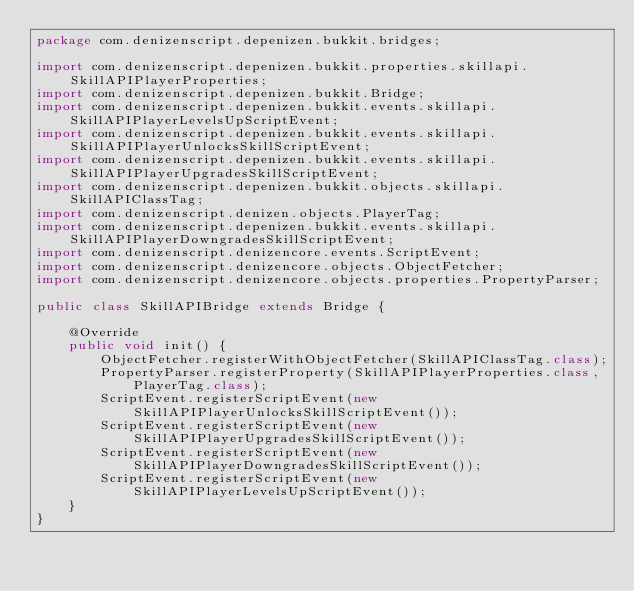<code> <loc_0><loc_0><loc_500><loc_500><_Java_>package com.denizenscript.depenizen.bukkit.bridges;

import com.denizenscript.depenizen.bukkit.properties.skillapi.SkillAPIPlayerProperties;
import com.denizenscript.depenizen.bukkit.Bridge;
import com.denizenscript.depenizen.bukkit.events.skillapi.SkillAPIPlayerLevelsUpScriptEvent;
import com.denizenscript.depenizen.bukkit.events.skillapi.SkillAPIPlayerUnlocksSkillScriptEvent;
import com.denizenscript.depenizen.bukkit.events.skillapi.SkillAPIPlayerUpgradesSkillScriptEvent;
import com.denizenscript.depenizen.bukkit.objects.skillapi.SkillAPIClassTag;
import com.denizenscript.denizen.objects.PlayerTag;
import com.denizenscript.depenizen.bukkit.events.skillapi.SkillAPIPlayerDowngradesSkillScriptEvent;
import com.denizenscript.denizencore.events.ScriptEvent;
import com.denizenscript.denizencore.objects.ObjectFetcher;
import com.denizenscript.denizencore.objects.properties.PropertyParser;

public class SkillAPIBridge extends Bridge {

    @Override
    public void init() {
        ObjectFetcher.registerWithObjectFetcher(SkillAPIClassTag.class);
        PropertyParser.registerProperty(SkillAPIPlayerProperties.class, PlayerTag.class);
        ScriptEvent.registerScriptEvent(new SkillAPIPlayerUnlocksSkillScriptEvent());
        ScriptEvent.registerScriptEvent(new SkillAPIPlayerUpgradesSkillScriptEvent());
        ScriptEvent.registerScriptEvent(new SkillAPIPlayerDowngradesSkillScriptEvent());
        ScriptEvent.registerScriptEvent(new SkillAPIPlayerLevelsUpScriptEvent());
    }
}
</code> 